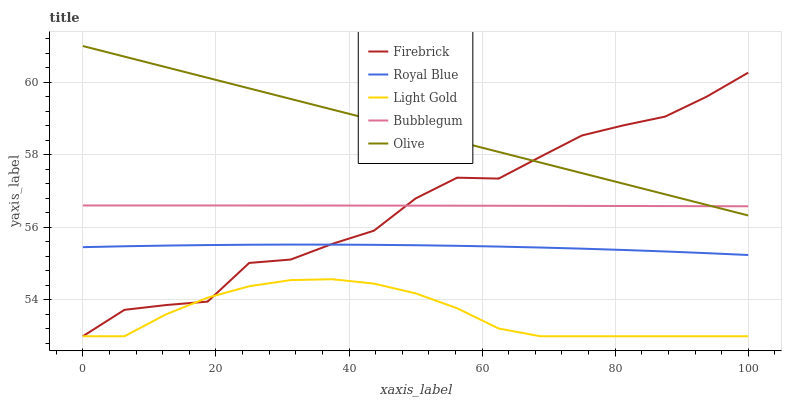Does Light Gold have the minimum area under the curve?
Answer yes or no. Yes. Does Olive have the maximum area under the curve?
Answer yes or no. Yes. Does Royal Blue have the minimum area under the curve?
Answer yes or no. No. Does Royal Blue have the maximum area under the curve?
Answer yes or no. No. Is Olive the smoothest?
Answer yes or no. Yes. Is Firebrick the roughest?
Answer yes or no. Yes. Is Royal Blue the smoothest?
Answer yes or no. No. Is Royal Blue the roughest?
Answer yes or no. No. Does Firebrick have the lowest value?
Answer yes or no. Yes. Does Royal Blue have the lowest value?
Answer yes or no. No. Does Olive have the highest value?
Answer yes or no. Yes. Does Royal Blue have the highest value?
Answer yes or no. No. Is Royal Blue less than Bubblegum?
Answer yes or no. Yes. Is Bubblegum greater than Royal Blue?
Answer yes or no. Yes. Does Firebrick intersect Olive?
Answer yes or no. Yes. Is Firebrick less than Olive?
Answer yes or no. No. Is Firebrick greater than Olive?
Answer yes or no. No. Does Royal Blue intersect Bubblegum?
Answer yes or no. No. 